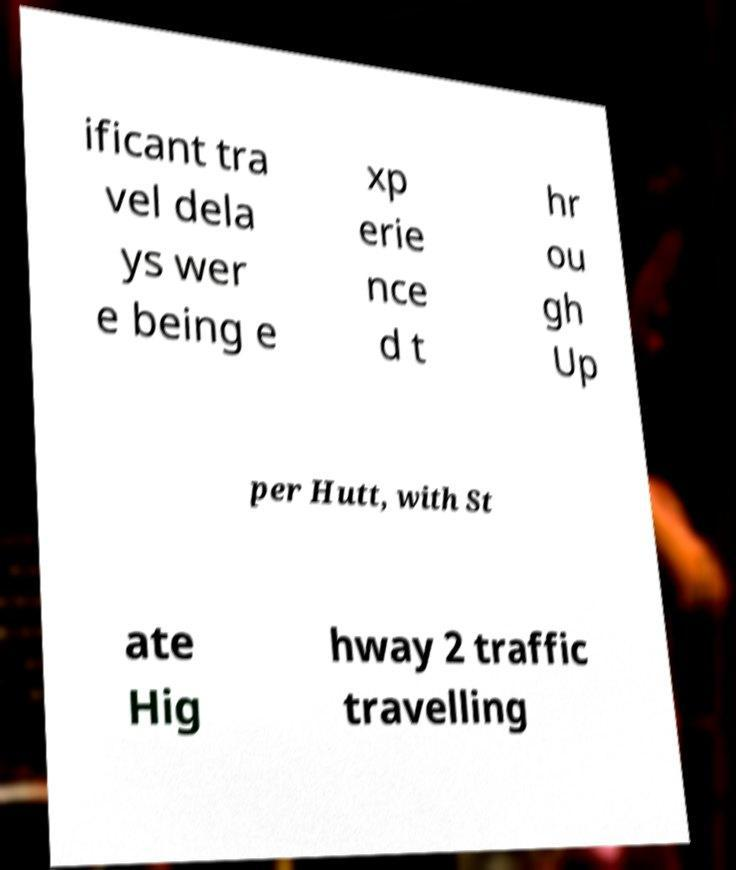For documentation purposes, I need the text within this image transcribed. Could you provide that? ificant tra vel dela ys wer e being e xp erie nce d t hr ou gh Up per Hutt, with St ate Hig hway 2 traffic travelling 